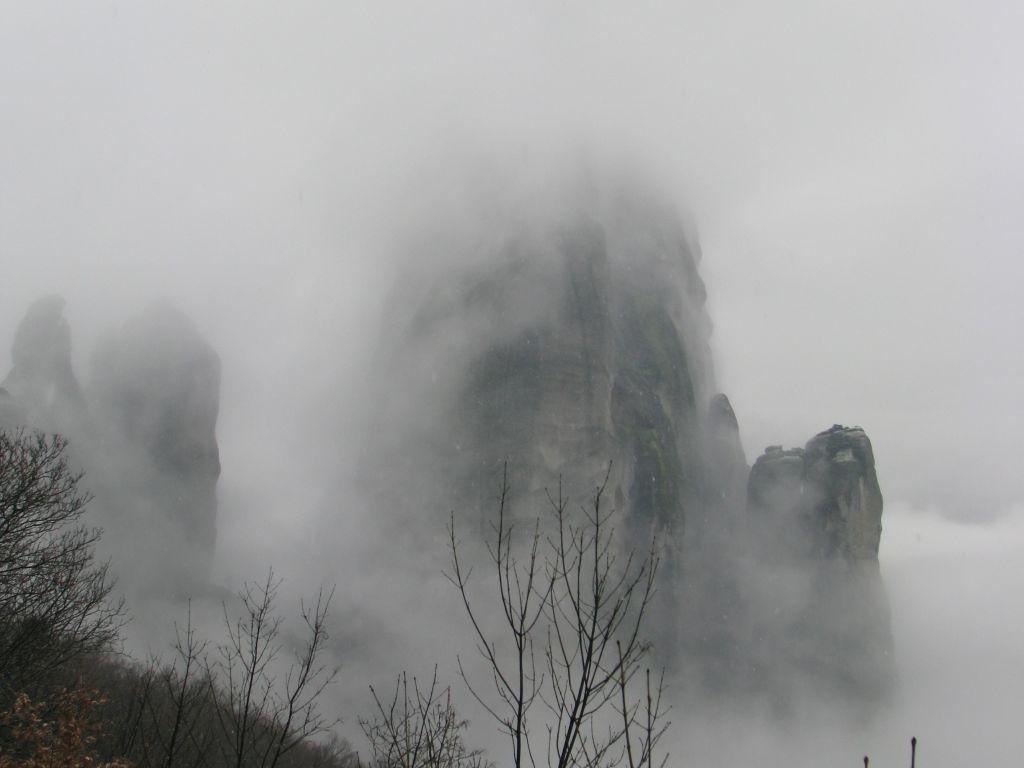What is the main feature in the center of the image? There is a hill in the center of the image. What can be seen in the image that is related to air pollution or a possible fire? There is smoke in the image. What type of vegetation is present at the bottom of the image? Trees, plants, and grass are visible at the bottom of the image. How does the zephyr affect the growth of the flower in the image? There is no flower present in the image, and the term "zephyr" refers to a gentle breeze, which is not mentioned in the provided facts. 